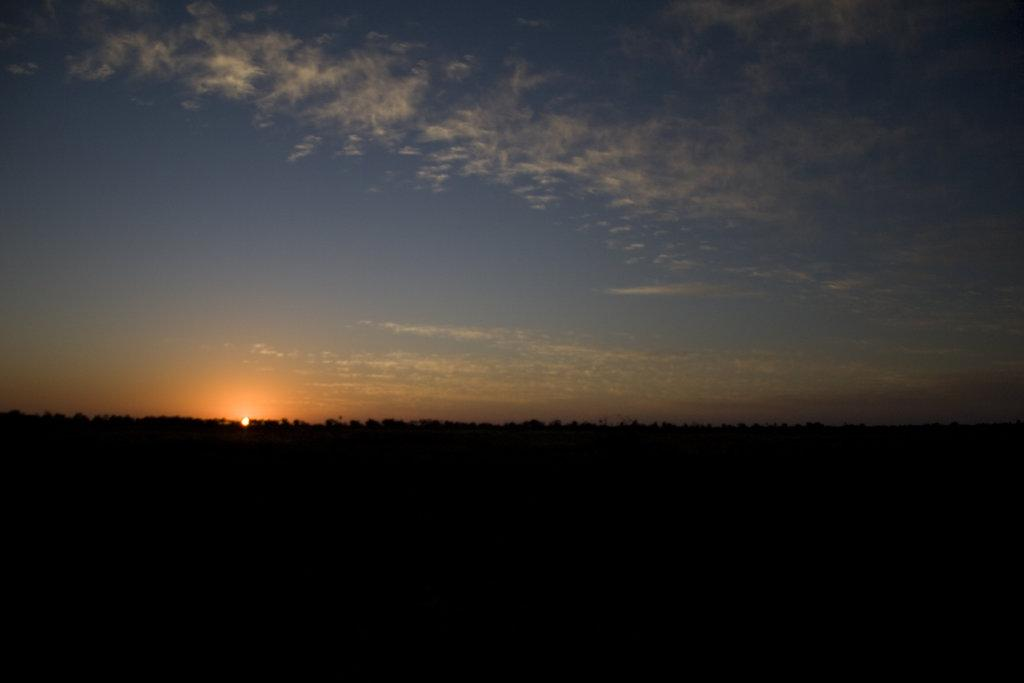What type of vegetation can be seen in the image? There are trees in the image. What celestial body is visible in the sky? The sun is visible in the sky. What is the interest rate on the trees in the image? There is no reference to interest rates in the image, as it features trees and the sun. Can you tell me how many times the trees cry in the image? Trees do not have the ability to cry, so this question cannot be answered. 